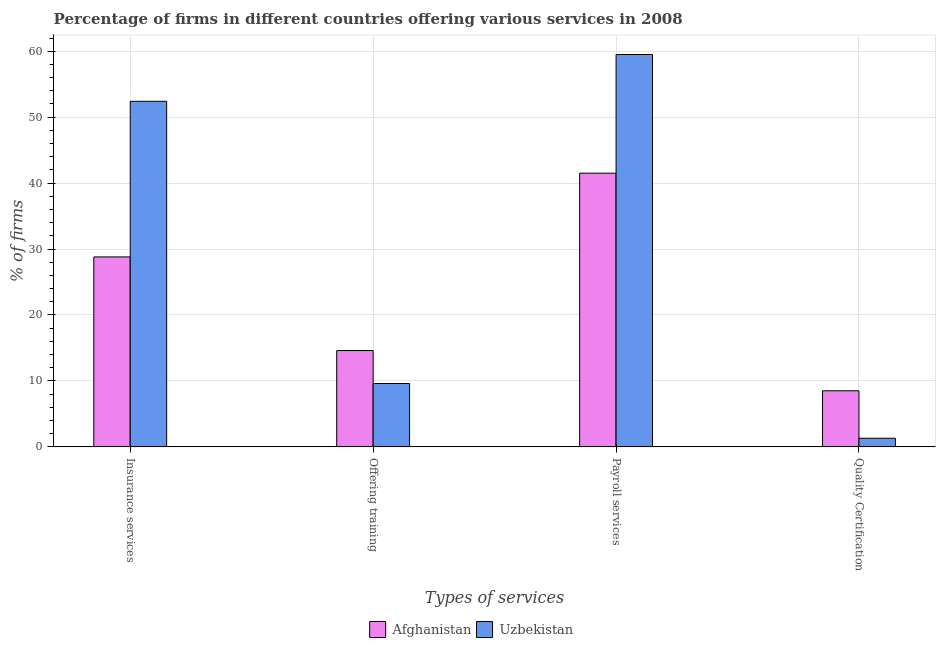How many different coloured bars are there?
Your response must be concise. 2. How many groups of bars are there?
Your answer should be very brief. 4. Are the number of bars per tick equal to the number of legend labels?
Keep it short and to the point. Yes. Are the number of bars on each tick of the X-axis equal?
Provide a short and direct response. Yes. What is the label of the 3rd group of bars from the left?
Your answer should be very brief. Payroll services. Across all countries, what is the maximum percentage of firms offering payroll services?
Offer a terse response. 59.5. In which country was the percentage of firms offering training maximum?
Provide a succinct answer. Afghanistan. In which country was the percentage of firms offering training minimum?
Your response must be concise. Uzbekistan. What is the total percentage of firms offering payroll services in the graph?
Keep it short and to the point. 101. What is the difference between the percentage of firms offering training in Uzbekistan and the percentage of firms offering quality certification in Afghanistan?
Provide a succinct answer. 1.1. What is the average percentage of firms offering training per country?
Give a very brief answer. 12.1. What is the difference between the percentage of firms offering quality certification and percentage of firms offering payroll services in Afghanistan?
Your answer should be compact. -33. In how many countries, is the percentage of firms offering training greater than 50 %?
Ensure brevity in your answer.  0. What is the ratio of the percentage of firms offering insurance services in Afghanistan to that in Uzbekistan?
Make the answer very short. 0.55. What is the difference between the highest and the lowest percentage of firms offering insurance services?
Your response must be concise. 23.6. Is it the case that in every country, the sum of the percentage of firms offering payroll services and percentage of firms offering training is greater than the sum of percentage of firms offering quality certification and percentage of firms offering insurance services?
Give a very brief answer. Yes. What does the 1st bar from the left in Quality Certification represents?
Offer a very short reply. Afghanistan. What does the 1st bar from the right in Insurance services represents?
Provide a short and direct response. Uzbekistan. How many bars are there?
Your answer should be compact. 8. How many countries are there in the graph?
Offer a very short reply. 2. What is the difference between two consecutive major ticks on the Y-axis?
Keep it short and to the point. 10. Does the graph contain any zero values?
Your answer should be very brief. No. Does the graph contain grids?
Your answer should be compact. Yes. Where does the legend appear in the graph?
Keep it short and to the point. Bottom center. How many legend labels are there?
Your answer should be compact. 2. How are the legend labels stacked?
Provide a short and direct response. Horizontal. What is the title of the graph?
Provide a short and direct response. Percentage of firms in different countries offering various services in 2008. Does "Uganda" appear as one of the legend labels in the graph?
Make the answer very short. No. What is the label or title of the X-axis?
Your response must be concise. Types of services. What is the label or title of the Y-axis?
Keep it short and to the point. % of firms. What is the % of firms in Afghanistan in Insurance services?
Your answer should be compact. 28.8. What is the % of firms in Uzbekistan in Insurance services?
Offer a very short reply. 52.4. What is the % of firms in Uzbekistan in Offering training?
Offer a terse response. 9.6. What is the % of firms in Afghanistan in Payroll services?
Offer a very short reply. 41.5. What is the % of firms of Uzbekistan in Payroll services?
Keep it short and to the point. 59.5. What is the % of firms of Afghanistan in Quality Certification?
Give a very brief answer. 8.5. What is the % of firms of Uzbekistan in Quality Certification?
Give a very brief answer. 1.3. Across all Types of services, what is the maximum % of firms of Afghanistan?
Your answer should be very brief. 41.5. Across all Types of services, what is the maximum % of firms of Uzbekistan?
Offer a terse response. 59.5. Across all Types of services, what is the minimum % of firms of Uzbekistan?
Offer a terse response. 1.3. What is the total % of firms of Afghanistan in the graph?
Your response must be concise. 93.4. What is the total % of firms in Uzbekistan in the graph?
Your answer should be compact. 122.8. What is the difference between the % of firms in Uzbekistan in Insurance services and that in Offering training?
Ensure brevity in your answer.  42.8. What is the difference between the % of firms of Afghanistan in Insurance services and that in Payroll services?
Provide a succinct answer. -12.7. What is the difference between the % of firms in Uzbekistan in Insurance services and that in Payroll services?
Ensure brevity in your answer.  -7.1. What is the difference between the % of firms in Afghanistan in Insurance services and that in Quality Certification?
Give a very brief answer. 20.3. What is the difference between the % of firms in Uzbekistan in Insurance services and that in Quality Certification?
Your answer should be compact. 51.1. What is the difference between the % of firms of Afghanistan in Offering training and that in Payroll services?
Your answer should be compact. -26.9. What is the difference between the % of firms in Uzbekistan in Offering training and that in Payroll services?
Give a very brief answer. -49.9. What is the difference between the % of firms in Uzbekistan in Offering training and that in Quality Certification?
Your answer should be very brief. 8.3. What is the difference between the % of firms of Uzbekistan in Payroll services and that in Quality Certification?
Your answer should be compact. 58.2. What is the difference between the % of firms in Afghanistan in Insurance services and the % of firms in Uzbekistan in Payroll services?
Offer a terse response. -30.7. What is the difference between the % of firms in Afghanistan in Offering training and the % of firms in Uzbekistan in Payroll services?
Your answer should be very brief. -44.9. What is the difference between the % of firms in Afghanistan in Payroll services and the % of firms in Uzbekistan in Quality Certification?
Make the answer very short. 40.2. What is the average % of firms of Afghanistan per Types of services?
Offer a terse response. 23.35. What is the average % of firms in Uzbekistan per Types of services?
Give a very brief answer. 30.7. What is the difference between the % of firms in Afghanistan and % of firms in Uzbekistan in Insurance services?
Make the answer very short. -23.6. What is the difference between the % of firms in Afghanistan and % of firms in Uzbekistan in Offering training?
Give a very brief answer. 5. What is the difference between the % of firms in Afghanistan and % of firms in Uzbekistan in Payroll services?
Your answer should be compact. -18. What is the difference between the % of firms in Afghanistan and % of firms in Uzbekistan in Quality Certification?
Offer a very short reply. 7.2. What is the ratio of the % of firms of Afghanistan in Insurance services to that in Offering training?
Offer a very short reply. 1.97. What is the ratio of the % of firms in Uzbekistan in Insurance services to that in Offering training?
Offer a very short reply. 5.46. What is the ratio of the % of firms in Afghanistan in Insurance services to that in Payroll services?
Offer a very short reply. 0.69. What is the ratio of the % of firms in Uzbekistan in Insurance services to that in Payroll services?
Provide a short and direct response. 0.88. What is the ratio of the % of firms in Afghanistan in Insurance services to that in Quality Certification?
Give a very brief answer. 3.39. What is the ratio of the % of firms of Uzbekistan in Insurance services to that in Quality Certification?
Provide a succinct answer. 40.31. What is the ratio of the % of firms in Afghanistan in Offering training to that in Payroll services?
Make the answer very short. 0.35. What is the ratio of the % of firms in Uzbekistan in Offering training to that in Payroll services?
Your response must be concise. 0.16. What is the ratio of the % of firms of Afghanistan in Offering training to that in Quality Certification?
Ensure brevity in your answer.  1.72. What is the ratio of the % of firms in Uzbekistan in Offering training to that in Quality Certification?
Provide a succinct answer. 7.38. What is the ratio of the % of firms in Afghanistan in Payroll services to that in Quality Certification?
Make the answer very short. 4.88. What is the ratio of the % of firms of Uzbekistan in Payroll services to that in Quality Certification?
Your answer should be very brief. 45.77. What is the difference between the highest and the second highest % of firms of Afghanistan?
Ensure brevity in your answer.  12.7. What is the difference between the highest and the lowest % of firms in Uzbekistan?
Offer a very short reply. 58.2. 